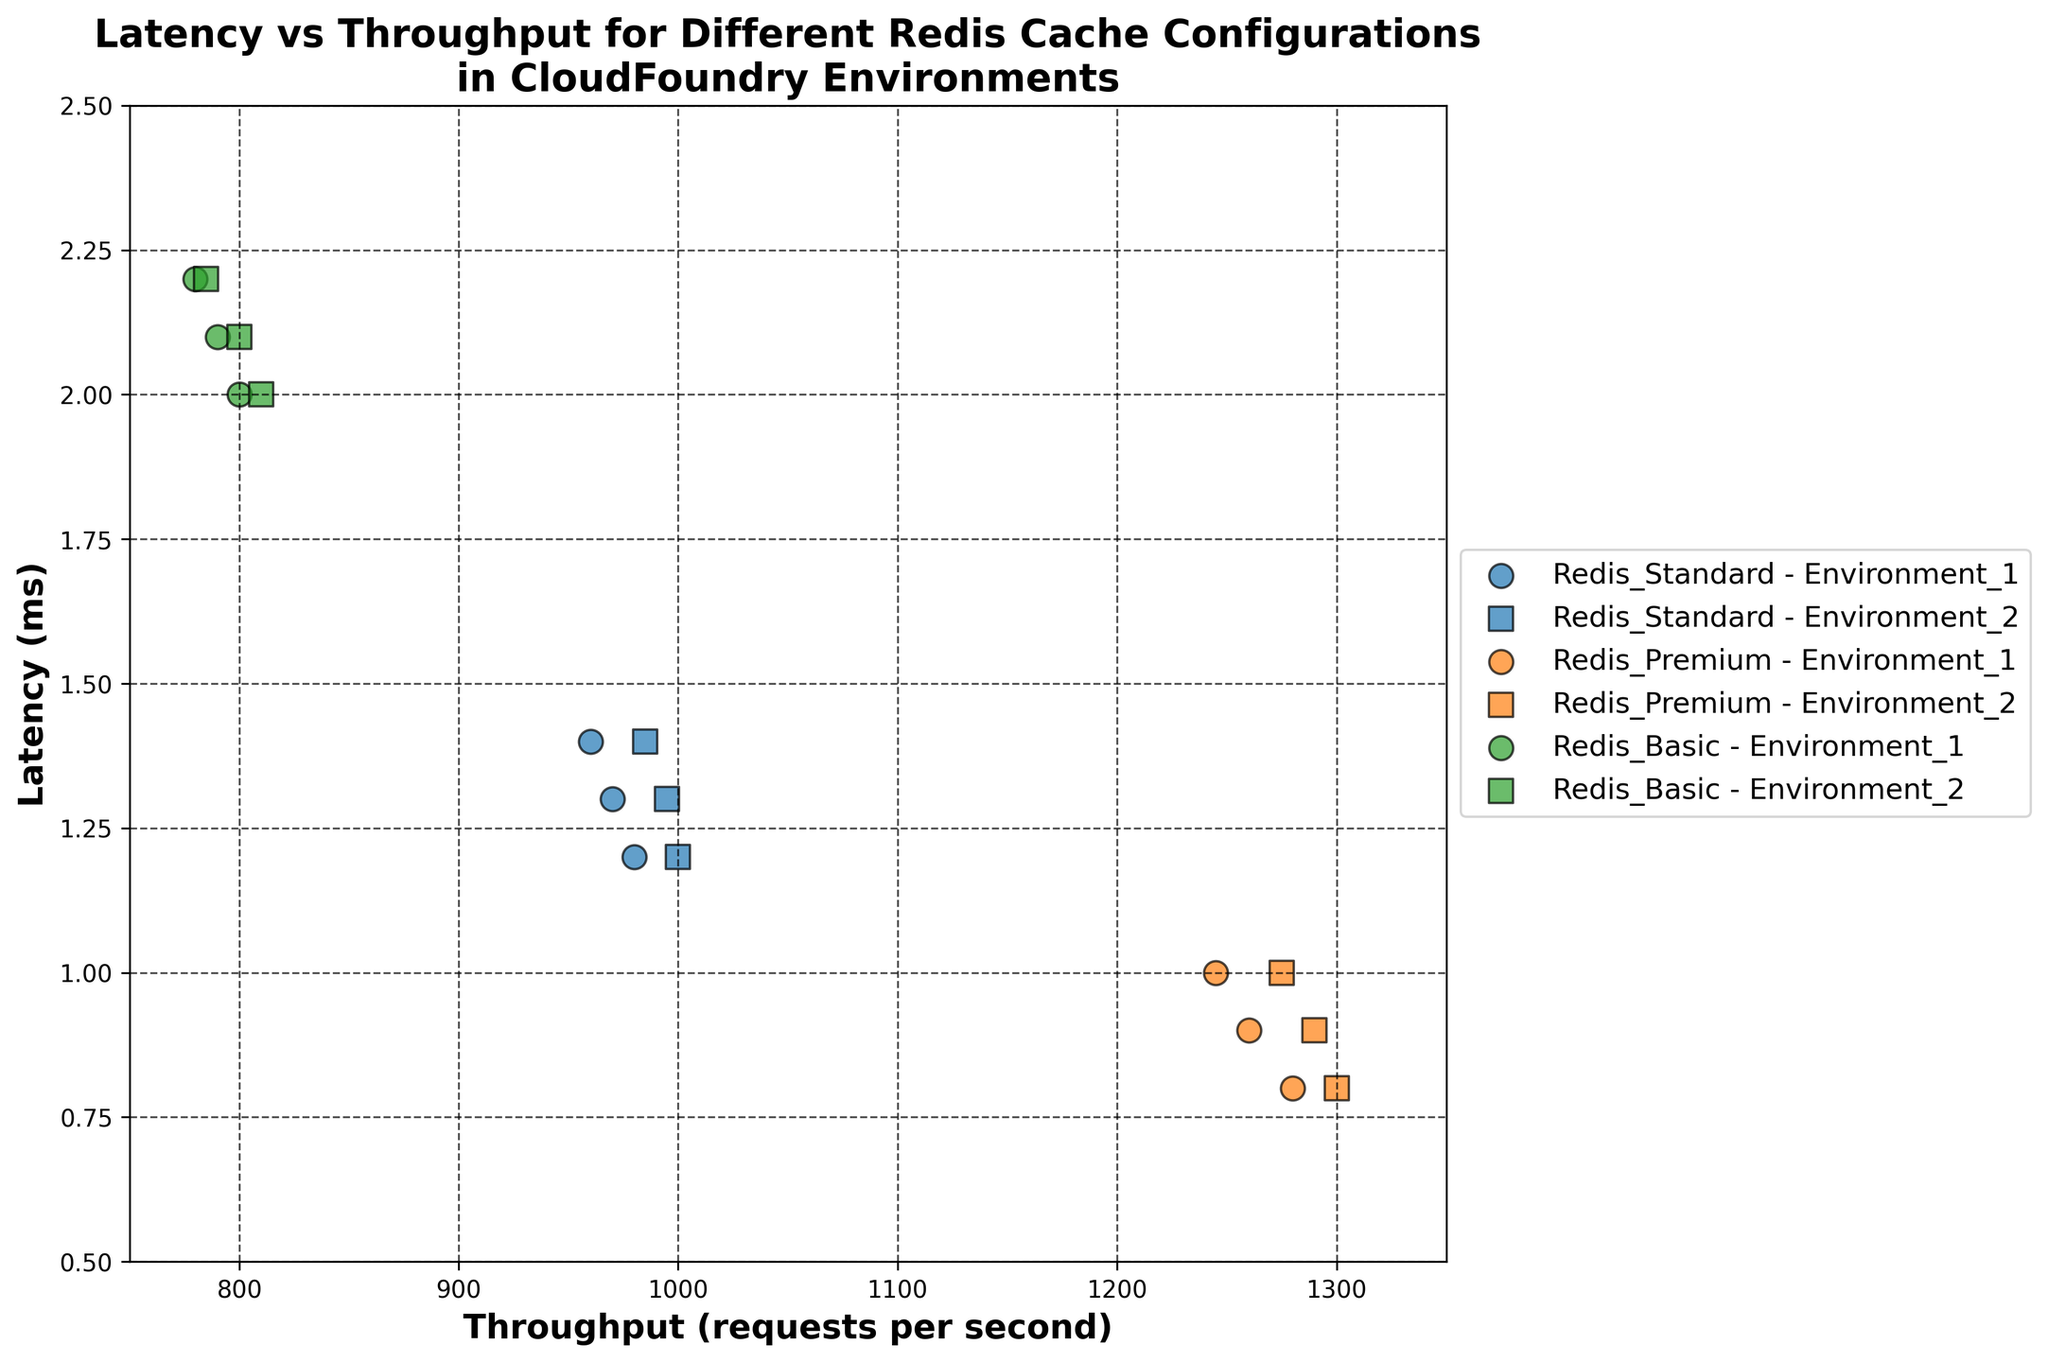What are the axes labels? The x-axis label is Throughput (requests per second), and the y-axis label is Latency (ms). These labels are located at the bottom and left of the plot, respectively.
Answer: Throughput (requests per second) and Latency (ms) How many data points are there for Redis Premium in Environment 1? The plot contains visual markers for each data point. By observing the plot, there are three circular markers (representing Environment 1) in the color assigned to Redis Premium.
Answer: 3 Which cache configuration has the lowest latency? To determine the lowest latency, look for the data points closest to the bottom of the y-axis. The plot shows that Redis Premium has the lowest latency with points at 0.8 ms, 0.9 ms, and 1.0 ms.
Answer: Redis Premium What is the average throughput for Redis Standard in Environment 2? The throughput values for Redis Standard in Environment 2 are 1000, 995, and 985 requests per second. The average is calculated as (1000 + 995 + 985) / 3 = 993.33 rps.
Answer: 993.33 rps Which environment provides better throughput performance for Redis Basic? Comparing the throughput values for Redis Basic in both environments, Environment 1 has throughput values of 800, 790, and 780, while Environment 2 has values of 810, 800, and 785. The higher throughputs are observed in Environment 2.
Answer: Environment 2 Which configuration shows the highest throughput overall? By observing the highest data point along the x-axis (higher throughput), Redis Premium in Environment 2 shows the highest throughput at 1300 requests per second.
Answer: Redis Premium (Environment 2) How does the latency compare between Redis Standard and Redis Basic in Environment 1? For Environment 1, compare the latency values: Redis Standard has latencies of 1.2 ms, 1.3 ms, and 1.4 ms, whereas Redis Basic has latencies of 2.0 ms, 2.1 ms, and 2.2 ms. Redis Standard has significantly lower latency values than Redis Basic.
Answer: Redis Standard has lower latency What is the range of throughput for Redis Premium in Environment 2? The throughput values for Redis Premium in Environment 2 range from 1275 to 1300 requests per second.
Answer: 1275-1300 rps Which configuration has the most consistent latency in Environment 1? Consistency can be observed by looking at the spread of the latency values. Redis Premium in Environment 1 has latency values close to each other (0.8 ms, 0.9 ms, and 1.0 ms), indicating high consistency.
Answer: Redis Premium What is the difference in average latency between Redis Standard and Redis Basic in Environment 2? For Redis Standard in Environment 2, the latencies are 1.2 ms, 1.3 ms, and 1.4 ms, averaging to (1.2 + 1.3 + 1.4) / 3 = 1.3 ms. For Redis Basic in Environment 2, the latencies are 2.0 ms, 2.1 ms, and 2.2 ms, averaging to (2.0 + 2.1 + 2.2) / 3 = 2.1 ms. The difference is 2.1 - 1.3 = 0.8 ms.
Answer: 0.8 ms 